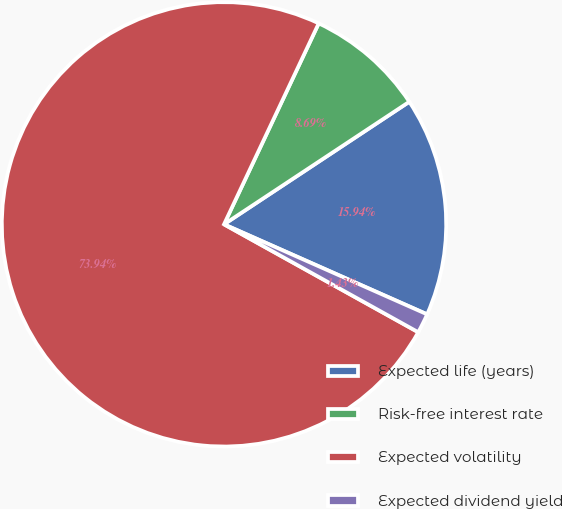Convert chart. <chart><loc_0><loc_0><loc_500><loc_500><pie_chart><fcel>Expected life (years)<fcel>Risk-free interest rate<fcel>Expected volatility<fcel>Expected dividend yield<nl><fcel>15.94%<fcel>8.69%<fcel>73.94%<fcel>1.43%<nl></chart> 